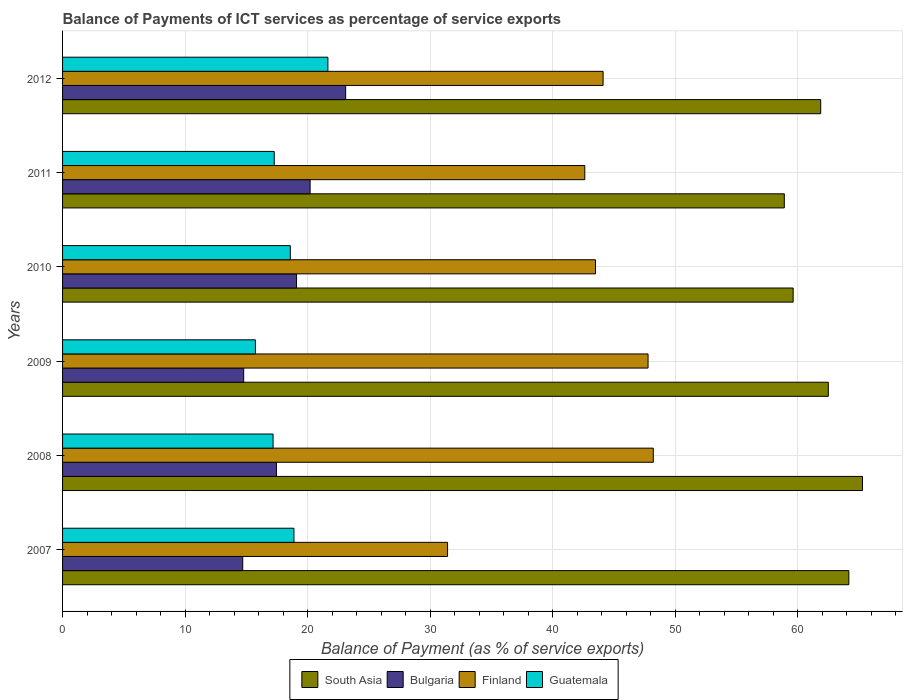How many groups of bars are there?
Provide a short and direct response. 6. Are the number of bars per tick equal to the number of legend labels?
Ensure brevity in your answer.  Yes. How many bars are there on the 2nd tick from the bottom?
Make the answer very short. 4. What is the label of the 1st group of bars from the top?
Provide a short and direct response. 2012. What is the balance of payments of ICT services in Bulgaria in 2008?
Offer a very short reply. 17.46. Across all years, what is the maximum balance of payments of ICT services in Guatemala?
Provide a short and direct response. 21.66. Across all years, what is the minimum balance of payments of ICT services in South Asia?
Your answer should be compact. 58.92. What is the total balance of payments of ICT services in Guatemala in the graph?
Keep it short and to the point. 109.34. What is the difference between the balance of payments of ICT services in Bulgaria in 2010 and that in 2012?
Keep it short and to the point. -4.01. What is the difference between the balance of payments of ICT services in Guatemala in 2011 and the balance of payments of ICT services in South Asia in 2007?
Provide a succinct answer. -46.91. What is the average balance of payments of ICT services in Guatemala per year?
Your answer should be very brief. 18.22. In the year 2007, what is the difference between the balance of payments of ICT services in Finland and balance of payments of ICT services in South Asia?
Give a very brief answer. -32.76. In how many years, is the balance of payments of ICT services in South Asia greater than 66 %?
Offer a terse response. 0. What is the ratio of the balance of payments of ICT services in Bulgaria in 2010 to that in 2011?
Your answer should be very brief. 0.95. Is the difference between the balance of payments of ICT services in Finland in 2010 and 2011 greater than the difference between the balance of payments of ICT services in South Asia in 2010 and 2011?
Ensure brevity in your answer.  Yes. What is the difference between the highest and the second highest balance of payments of ICT services in South Asia?
Ensure brevity in your answer.  1.11. What is the difference between the highest and the lowest balance of payments of ICT services in Finland?
Make the answer very short. 16.8. In how many years, is the balance of payments of ICT services in Guatemala greater than the average balance of payments of ICT services in Guatemala taken over all years?
Provide a short and direct response. 3. Is the sum of the balance of payments of ICT services in Guatemala in 2007 and 2009 greater than the maximum balance of payments of ICT services in Bulgaria across all years?
Your answer should be compact. Yes. Is it the case that in every year, the sum of the balance of payments of ICT services in Bulgaria and balance of payments of ICT services in Guatemala is greater than the sum of balance of payments of ICT services in South Asia and balance of payments of ICT services in Finland?
Give a very brief answer. No. What does the 3rd bar from the bottom in 2012 represents?
Your response must be concise. Finland. Is it the case that in every year, the sum of the balance of payments of ICT services in Finland and balance of payments of ICT services in Guatemala is greater than the balance of payments of ICT services in Bulgaria?
Provide a short and direct response. Yes. How many bars are there?
Provide a short and direct response. 24. Are all the bars in the graph horizontal?
Your answer should be very brief. Yes. How many years are there in the graph?
Make the answer very short. 6. Does the graph contain grids?
Give a very brief answer. Yes. How are the legend labels stacked?
Keep it short and to the point. Horizontal. What is the title of the graph?
Offer a very short reply. Balance of Payments of ICT services as percentage of service exports. What is the label or title of the X-axis?
Your answer should be compact. Balance of Payment (as % of service exports). What is the label or title of the Y-axis?
Offer a terse response. Years. What is the Balance of Payment (as % of service exports) of South Asia in 2007?
Keep it short and to the point. 64.18. What is the Balance of Payment (as % of service exports) of Bulgaria in 2007?
Your response must be concise. 14.71. What is the Balance of Payment (as % of service exports) of Finland in 2007?
Offer a terse response. 31.43. What is the Balance of Payment (as % of service exports) of Guatemala in 2007?
Provide a short and direct response. 18.89. What is the Balance of Payment (as % of service exports) of South Asia in 2008?
Ensure brevity in your answer.  65.3. What is the Balance of Payment (as % of service exports) in Bulgaria in 2008?
Keep it short and to the point. 17.46. What is the Balance of Payment (as % of service exports) of Finland in 2008?
Your answer should be compact. 48.22. What is the Balance of Payment (as % of service exports) of Guatemala in 2008?
Keep it short and to the point. 17.18. What is the Balance of Payment (as % of service exports) of South Asia in 2009?
Provide a succinct answer. 62.51. What is the Balance of Payment (as % of service exports) in Bulgaria in 2009?
Provide a short and direct response. 14.78. What is the Balance of Payment (as % of service exports) of Finland in 2009?
Your answer should be compact. 47.79. What is the Balance of Payment (as % of service exports) in Guatemala in 2009?
Your answer should be very brief. 15.74. What is the Balance of Payment (as % of service exports) in South Asia in 2010?
Give a very brief answer. 59.64. What is the Balance of Payment (as % of service exports) in Bulgaria in 2010?
Your response must be concise. 19.1. What is the Balance of Payment (as % of service exports) of Finland in 2010?
Give a very brief answer. 43.5. What is the Balance of Payment (as % of service exports) in Guatemala in 2010?
Your response must be concise. 18.59. What is the Balance of Payment (as % of service exports) in South Asia in 2011?
Offer a terse response. 58.92. What is the Balance of Payment (as % of service exports) in Bulgaria in 2011?
Your answer should be very brief. 20.21. What is the Balance of Payment (as % of service exports) of Finland in 2011?
Make the answer very short. 42.63. What is the Balance of Payment (as % of service exports) of Guatemala in 2011?
Give a very brief answer. 17.28. What is the Balance of Payment (as % of service exports) in South Asia in 2012?
Provide a succinct answer. 61.89. What is the Balance of Payment (as % of service exports) in Bulgaria in 2012?
Ensure brevity in your answer.  23.11. What is the Balance of Payment (as % of service exports) of Finland in 2012?
Your response must be concise. 44.12. What is the Balance of Payment (as % of service exports) of Guatemala in 2012?
Offer a terse response. 21.66. Across all years, what is the maximum Balance of Payment (as % of service exports) of South Asia?
Keep it short and to the point. 65.3. Across all years, what is the maximum Balance of Payment (as % of service exports) in Bulgaria?
Ensure brevity in your answer.  23.11. Across all years, what is the maximum Balance of Payment (as % of service exports) in Finland?
Provide a short and direct response. 48.22. Across all years, what is the maximum Balance of Payment (as % of service exports) in Guatemala?
Offer a terse response. 21.66. Across all years, what is the minimum Balance of Payment (as % of service exports) of South Asia?
Your answer should be very brief. 58.92. Across all years, what is the minimum Balance of Payment (as % of service exports) of Bulgaria?
Offer a very short reply. 14.71. Across all years, what is the minimum Balance of Payment (as % of service exports) in Finland?
Your response must be concise. 31.43. Across all years, what is the minimum Balance of Payment (as % of service exports) of Guatemala?
Give a very brief answer. 15.74. What is the total Balance of Payment (as % of service exports) of South Asia in the graph?
Your answer should be compact. 372.43. What is the total Balance of Payment (as % of service exports) in Bulgaria in the graph?
Make the answer very short. 109.37. What is the total Balance of Payment (as % of service exports) of Finland in the graph?
Ensure brevity in your answer.  257.7. What is the total Balance of Payment (as % of service exports) in Guatemala in the graph?
Provide a short and direct response. 109.34. What is the difference between the Balance of Payment (as % of service exports) of South Asia in 2007 and that in 2008?
Provide a short and direct response. -1.11. What is the difference between the Balance of Payment (as % of service exports) in Bulgaria in 2007 and that in 2008?
Ensure brevity in your answer.  -2.75. What is the difference between the Balance of Payment (as % of service exports) of Finland in 2007 and that in 2008?
Offer a terse response. -16.8. What is the difference between the Balance of Payment (as % of service exports) in Guatemala in 2007 and that in 2008?
Ensure brevity in your answer.  1.71. What is the difference between the Balance of Payment (as % of service exports) in South Asia in 2007 and that in 2009?
Provide a short and direct response. 1.68. What is the difference between the Balance of Payment (as % of service exports) in Bulgaria in 2007 and that in 2009?
Keep it short and to the point. -0.08. What is the difference between the Balance of Payment (as % of service exports) of Finland in 2007 and that in 2009?
Your answer should be compact. -16.37. What is the difference between the Balance of Payment (as % of service exports) in Guatemala in 2007 and that in 2009?
Your answer should be compact. 3.15. What is the difference between the Balance of Payment (as % of service exports) in South Asia in 2007 and that in 2010?
Provide a short and direct response. 4.54. What is the difference between the Balance of Payment (as % of service exports) in Bulgaria in 2007 and that in 2010?
Your response must be concise. -4.39. What is the difference between the Balance of Payment (as % of service exports) of Finland in 2007 and that in 2010?
Make the answer very short. -12.08. What is the difference between the Balance of Payment (as % of service exports) of Guatemala in 2007 and that in 2010?
Provide a succinct answer. 0.3. What is the difference between the Balance of Payment (as % of service exports) of South Asia in 2007 and that in 2011?
Ensure brevity in your answer.  5.27. What is the difference between the Balance of Payment (as % of service exports) of Bulgaria in 2007 and that in 2011?
Keep it short and to the point. -5.5. What is the difference between the Balance of Payment (as % of service exports) in Finland in 2007 and that in 2011?
Keep it short and to the point. -11.2. What is the difference between the Balance of Payment (as % of service exports) in Guatemala in 2007 and that in 2011?
Ensure brevity in your answer.  1.61. What is the difference between the Balance of Payment (as % of service exports) of South Asia in 2007 and that in 2012?
Make the answer very short. 2.3. What is the difference between the Balance of Payment (as % of service exports) of Bulgaria in 2007 and that in 2012?
Provide a short and direct response. -8.4. What is the difference between the Balance of Payment (as % of service exports) of Finland in 2007 and that in 2012?
Give a very brief answer. -12.7. What is the difference between the Balance of Payment (as % of service exports) in Guatemala in 2007 and that in 2012?
Your response must be concise. -2.77. What is the difference between the Balance of Payment (as % of service exports) in South Asia in 2008 and that in 2009?
Give a very brief answer. 2.79. What is the difference between the Balance of Payment (as % of service exports) of Bulgaria in 2008 and that in 2009?
Provide a succinct answer. 2.67. What is the difference between the Balance of Payment (as % of service exports) of Finland in 2008 and that in 2009?
Provide a succinct answer. 0.43. What is the difference between the Balance of Payment (as % of service exports) of Guatemala in 2008 and that in 2009?
Provide a succinct answer. 1.44. What is the difference between the Balance of Payment (as % of service exports) in South Asia in 2008 and that in 2010?
Provide a short and direct response. 5.66. What is the difference between the Balance of Payment (as % of service exports) of Bulgaria in 2008 and that in 2010?
Your response must be concise. -1.64. What is the difference between the Balance of Payment (as % of service exports) of Finland in 2008 and that in 2010?
Your answer should be compact. 4.72. What is the difference between the Balance of Payment (as % of service exports) in Guatemala in 2008 and that in 2010?
Provide a short and direct response. -1.41. What is the difference between the Balance of Payment (as % of service exports) in South Asia in 2008 and that in 2011?
Keep it short and to the point. 6.38. What is the difference between the Balance of Payment (as % of service exports) in Bulgaria in 2008 and that in 2011?
Make the answer very short. -2.75. What is the difference between the Balance of Payment (as % of service exports) in Finland in 2008 and that in 2011?
Offer a terse response. 5.59. What is the difference between the Balance of Payment (as % of service exports) of Guatemala in 2008 and that in 2011?
Give a very brief answer. -0.09. What is the difference between the Balance of Payment (as % of service exports) in South Asia in 2008 and that in 2012?
Provide a short and direct response. 3.41. What is the difference between the Balance of Payment (as % of service exports) of Bulgaria in 2008 and that in 2012?
Your response must be concise. -5.65. What is the difference between the Balance of Payment (as % of service exports) in Finland in 2008 and that in 2012?
Make the answer very short. 4.1. What is the difference between the Balance of Payment (as % of service exports) in Guatemala in 2008 and that in 2012?
Offer a terse response. -4.48. What is the difference between the Balance of Payment (as % of service exports) of South Asia in 2009 and that in 2010?
Provide a succinct answer. 2.87. What is the difference between the Balance of Payment (as % of service exports) in Bulgaria in 2009 and that in 2010?
Offer a terse response. -4.31. What is the difference between the Balance of Payment (as % of service exports) in Finland in 2009 and that in 2010?
Your answer should be very brief. 4.29. What is the difference between the Balance of Payment (as % of service exports) of Guatemala in 2009 and that in 2010?
Keep it short and to the point. -2.85. What is the difference between the Balance of Payment (as % of service exports) of South Asia in 2009 and that in 2011?
Provide a succinct answer. 3.59. What is the difference between the Balance of Payment (as % of service exports) of Bulgaria in 2009 and that in 2011?
Ensure brevity in your answer.  -5.42. What is the difference between the Balance of Payment (as % of service exports) of Finland in 2009 and that in 2011?
Your answer should be compact. 5.16. What is the difference between the Balance of Payment (as % of service exports) of Guatemala in 2009 and that in 2011?
Your answer should be very brief. -1.54. What is the difference between the Balance of Payment (as % of service exports) of South Asia in 2009 and that in 2012?
Provide a succinct answer. 0.62. What is the difference between the Balance of Payment (as % of service exports) in Bulgaria in 2009 and that in 2012?
Offer a terse response. -8.32. What is the difference between the Balance of Payment (as % of service exports) in Finland in 2009 and that in 2012?
Offer a terse response. 3.67. What is the difference between the Balance of Payment (as % of service exports) in Guatemala in 2009 and that in 2012?
Your response must be concise. -5.92. What is the difference between the Balance of Payment (as % of service exports) in South Asia in 2010 and that in 2011?
Keep it short and to the point. 0.72. What is the difference between the Balance of Payment (as % of service exports) in Bulgaria in 2010 and that in 2011?
Offer a very short reply. -1.11. What is the difference between the Balance of Payment (as % of service exports) in Finland in 2010 and that in 2011?
Offer a very short reply. 0.87. What is the difference between the Balance of Payment (as % of service exports) of Guatemala in 2010 and that in 2011?
Give a very brief answer. 1.31. What is the difference between the Balance of Payment (as % of service exports) of South Asia in 2010 and that in 2012?
Keep it short and to the point. -2.25. What is the difference between the Balance of Payment (as % of service exports) in Bulgaria in 2010 and that in 2012?
Provide a short and direct response. -4.01. What is the difference between the Balance of Payment (as % of service exports) in Finland in 2010 and that in 2012?
Your response must be concise. -0.62. What is the difference between the Balance of Payment (as % of service exports) of Guatemala in 2010 and that in 2012?
Your answer should be compact. -3.07. What is the difference between the Balance of Payment (as % of service exports) of South Asia in 2011 and that in 2012?
Your answer should be very brief. -2.97. What is the difference between the Balance of Payment (as % of service exports) in Bulgaria in 2011 and that in 2012?
Your answer should be very brief. -2.9. What is the difference between the Balance of Payment (as % of service exports) in Finland in 2011 and that in 2012?
Your answer should be very brief. -1.49. What is the difference between the Balance of Payment (as % of service exports) of Guatemala in 2011 and that in 2012?
Offer a very short reply. -4.38. What is the difference between the Balance of Payment (as % of service exports) of South Asia in 2007 and the Balance of Payment (as % of service exports) of Bulgaria in 2008?
Offer a terse response. 46.73. What is the difference between the Balance of Payment (as % of service exports) in South Asia in 2007 and the Balance of Payment (as % of service exports) in Finland in 2008?
Offer a terse response. 15.96. What is the difference between the Balance of Payment (as % of service exports) of South Asia in 2007 and the Balance of Payment (as % of service exports) of Guatemala in 2008?
Your answer should be compact. 47. What is the difference between the Balance of Payment (as % of service exports) of Bulgaria in 2007 and the Balance of Payment (as % of service exports) of Finland in 2008?
Give a very brief answer. -33.51. What is the difference between the Balance of Payment (as % of service exports) of Bulgaria in 2007 and the Balance of Payment (as % of service exports) of Guatemala in 2008?
Ensure brevity in your answer.  -2.48. What is the difference between the Balance of Payment (as % of service exports) in Finland in 2007 and the Balance of Payment (as % of service exports) in Guatemala in 2008?
Your answer should be compact. 14.24. What is the difference between the Balance of Payment (as % of service exports) in South Asia in 2007 and the Balance of Payment (as % of service exports) in Bulgaria in 2009?
Keep it short and to the point. 49.4. What is the difference between the Balance of Payment (as % of service exports) in South Asia in 2007 and the Balance of Payment (as % of service exports) in Finland in 2009?
Make the answer very short. 16.39. What is the difference between the Balance of Payment (as % of service exports) in South Asia in 2007 and the Balance of Payment (as % of service exports) in Guatemala in 2009?
Keep it short and to the point. 48.44. What is the difference between the Balance of Payment (as % of service exports) of Bulgaria in 2007 and the Balance of Payment (as % of service exports) of Finland in 2009?
Ensure brevity in your answer.  -33.09. What is the difference between the Balance of Payment (as % of service exports) in Bulgaria in 2007 and the Balance of Payment (as % of service exports) in Guatemala in 2009?
Provide a short and direct response. -1.03. What is the difference between the Balance of Payment (as % of service exports) of Finland in 2007 and the Balance of Payment (as % of service exports) of Guatemala in 2009?
Keep it short and to the point. 15.69. What is the difference between the Balance of Payment (as % of service exports) of South Asia in 2007 and the Balance of Payment (as % of service exports) of Bulgaria in 2010?
Keep it short and to the point. 45.08. What is the difference between the Balance of Payment (as % of service exports) of South Asia in 2007 and the Balance of Payment (as % of service exports) of Finland in 2010?
Make the answer very short. 20.68. What is the difference between the Balance of Payment (as % of service exports) of South Asia in 2007 and the Balance of Payment (as % of service exports) of Guatemala in 2010?
Provide a succinct answer. 45.59. What is the difference between the Balance of Payment (as % of service exports) in Bulgaria in 2007 and the Balance of Payment (as % of service exports) in Finland in 2010?
Ensure brevity in your answer.  -28.79. What is the difference between the Balance of Payment (as % of service exports) of Bulgaria in 2007 and the Balance of Payment (as % of service exports) of Guatemala in 2010?
Keep it short and to the point. -3.88. What is the difference between the Balance of Payment (as % of service exports) of Finland in 2007 and the Balance of Payment (as % of service exports) of Guatemala in 2010?
Make the answer very short. 12.84. What is the difference between the Balance of Payment (as % of service exports) in South Asia in 2007 and the Balance of Payment (as % of service exports) in Bulgaria in 2011?
Provide a succinct answer. 43.98. What is the difference between the Balance of Payment (as % of service exports) in South Asia in 2007 and the Balance of Payment (as % of service exports) in Finland in 2011?
Provide a succinct answer. 21.55. What is the difference between the Balance of Payment (as % of service exports) in South Asia in 2007 and the Balance of Payment (as % of service exports) in Guatemala in 2011?
Provide a succinct answer. 46.91. What is the difference between the Balance of Payment (as % of service exports) in Bulgaria in 2007 and the Balance of Payment (as % of service exports) in Finland in 2011?
Offer a very short reply. -27.92. What is the difference between the Balance of Payment (as % of service exports) in Bulgaria in 2007 and the Balance of Payment (as % of service exports) in Guatemala in 2011?
Provide a succinct answer. -2.57. What is the difference between the Balance of Payment (as % of service exports) in Finland in 2007 and the Balance of Payment (as % of service exports) in Guatemala in 2011?
Ensure brevity in your answer.  14.15. What is the difference between the Balance of Payment (as % of service exports) in South Asia in 2007 and the Balance of Payment (as % of service exports) in Bulgaria in 2012?
Keep it short and to the point. 41.07. What is the difference between the Balance of Payment (as % of service exports) in South Asia in 2007 and the Balance of Payment (as % of service exports) in Finland in 2012?
Provide a short and direct response. 20.06. What is the difference between the Balance of Payment (as % of service exports) in South Asia in 2007 and the Balance of Payment (as % of service exports) in Guatemala in 2012?
Offer a very short reply. 42.52. What is the difference between the Balance of Payment (as % of service exports) of Bulgaria in 2007 and the Balance of Payment (as % of service exports) of Finland in 2012?
Your answer should be very brief. -29.42. What is the difference between the Balance of Payment (as % of service exports) in Bulgaria in 2007 and the Balance of Payment (as % of service exports) in Guatemala in 2012?
Offer a very short reply. -6.95. What is the difference between the Balance of Payment (as % of service exports) in Finland in 2007 and the Balance of Payment (as % of service exports) in Guatemala in 2012?
Provide a succinct answer. 9.77. What is the difference between the Balance of Payment (as % of service exports) of South Asia in 2008 and the Balance of Payment (as % of service exports) of Bulgaria in 2009?
Provide a succinct answer. 50.51. What is the difference between the Balance of Payment (as % of service exports) of South Asia in 2008 and the Balance of Payment (as % of service exports) of Finland in 2009?
Your answer should be compact. 17.5. What is the difference between the Balance of Payment (as % of service exports) in South Asia in 2008 and the Balance of Payment (as % of service exports) in Guatemala in 2009?
Offer a terse response. 49.56. What is the difference between the Balance of Payment (as % of service exports) in Bulgaria in 2008 and the Balance of Payment (as % of service exports) in Finland in 2009?
Your response must be concise. -30.34. What is the difference between the Balance of Payment (as % of service exports) of Bulgaria in 2008 and the Balance of Payment (as % of service exports) of Guatemala in 2009?
Offer a terse response. 1.72. What is the difference between the Balance of Payment (as % of service exports) of Finland in 2008 and the Balance of Payment (as % of service exports) of Guatemala in 2009?
Offer a terse response. 32.48. What is the difference between the Balance of Payment (as % of service exports) of South Asia in 2008 and the Balance of Payment (as % of service exports) of Bulgaria in 2010?
Offer a very short reply. 46.2. What is the difference between the Balance of Payment (as % of service exports) of South Asia in 2008 and the Balance of Payment (as % of service exports) of Finland in 2010?
Your answer should be very brief. 21.8. What is the difference between the Balance of Payment (as % of service exports) of South Asia in 2008 and the Balance of Payment (as % of service exports) of Guatemala in 2010?
Offer a very short reply. 46.71. What is the difference between the Balance of Payment (as % of service exports) of Bulgaria in 2008 and the Balance of Payment (as % of service exports) of Finland in 2010?
Provide a short and direct response. -26.04. What is the difference between the Balance of Payment (as % of service exports) in Bulgaria in 2008 and the Balance of Payment (as % of service exports) in Guatemala in 2010?
Offer a very short reply. -1.13. What is the difference between the Balance of Payment (as % of service exports) of Finland in 2008 and the Balance of Payment (as % of service exports) of Guatemala in 2010?
Make the answer very short. 29.63. What is the difference between the Balance of Payment (as % of service exports) in South Asia in 2008 and the Balance of Payment (as % of service exports) in Bulgaria in 2011?
Your answer should be very brief. 45.09. What is the difference between the Balance of Payment (as % of service exports) in South Asia in 2008 and the Balance of Payment (as % of service exports) in Finland in 2011?
Make the answer very short. 22.67. What is the difference between the Balance of Payment (as % of service exports) of South Asia in 2008 and the Balance of Payment (as % of service exports) of Guatemala in 2011?
Provide a short and direct response. 48.02. What is the difference between the Balance of Payment (as % of service exports) of Bulgaria in 2008 and the Balance of Payment (as % of service exports) of Finland in 2011?
Make the answer very short. -25.17. What is the difference between the Balance of Payment (as % of service exports) of Bulgaria in 2008 and the Balance of Payment (as % of service exports) of Guatemala in 2011?
Offer a terse response. 0.18. What is the difference between the Balance of Payment (as % of service exports) in Finland in 2008 and the Balance of Payment (as % of service exports) in Guatemala in 2011?
Offer a very short reply. 30.94. What is the difference between the Balance of Payment (as % of service exports) of South Asia in 2008 and the Balance of Payment (as % of service exports) of Bulgaria in 2012?
Ensure brevity in your answer.  42.19. What is the difference between the Balance of Payment (as % of service exports) in South Asia in 2008 and the Balance of Payment (as % of service exports) in Finland in 2012?
Provide a short and direct response. 21.17. What is the difference between the Balance of Payment (as % of service exports) of South Asia in 2008 and the Balance of Payment (as % of service exports) of Guatemala in 2012?
Ensure brevity in your answer.  43.64. What is the difference between the Balance of Payment (as % of service exports) in Bulgaria in 2008 and the Balance of Payment (as % of service exports) in Finland in 2012?
Provide a succinct answer. -26.67. What is the difference between the Balance of Payment (as % of service exports) of Bulgaria in 2008 and the Balance of Payment (as % of service exports) of Guatemala in 2012?
Make the answer very short. -4.2. What is the difference between the Balance of Payment (as % of service exports) of Finland in 2008 and the Balance of Payment (as % of service exports) of Guatemala in 2012?
Offer a terse response. 26.56. What is the difference between the Balance of Payment (as % of service exports) in South Asia in 2009 and the Balance of Payment (as % of service exports) in Bulgaria in 2010?
Keep it short and to the point. 43.41. What is the difference between the Balance of Payment (as % of service exports) of South Asia in 2009 and the Balance of Payment (as % of service exports) of Finland in 2010?
Keep it short and to the point. 19.01. What is the difference between the Balance of Payment (as % of service exports) in South Asia in 2009 and the Balance of Payment (as % of service exports) in Guatemala in 2010?
Give a very brief answer. 43.92. What is the difference between the Balance of Payment (as % of service exports) of Bulgaria in 2009 and the Balance of Payment (as % of service exports) of Finland in 2010?
Provide a short and direct response. -28.72. What is the difference between the Balance of Payment (as % of service exports) of Bulgaria in 2009 and the Balance of Payment (as % of service exports) of Guatemala in 2010?
Provide a succinct answer. -3.81. What is the difference between the Balance of Payment (as % of service exports) of Finland in 2009 and the Balance of Payment (as % of service exports) of Guatemala in 2010?
Keep it short and to the point. 29.2. What is the difference between the Balance of Payment (as % of service exports) of South Asia in 2009 and the Balance of Payment (as % of service exports) of Bulgaria in 2011?
Ensure brevity in your answer.  42.3. What is the difference between the Balance of Payment (as % of service exports) in South Asia in 2009 and the Balance of Payment (as % of service exports) in Finland in 2011?
Offer a very short reply. 19.88. What is the difference between the Balance of Payment (as % of service exports) in South Asia in 2009 and the Balance of Payment (as % of service exports) in Guatemala in 2011?
Your answer should be very brief. 45.23. What is the difference between the Balance of Payment (as % of service exports) in Bulgaria in 2009 and the Balance of Payment (as % of service exports) in Finland in 2011?
Provide a succinct answer. -27.85. What is the difference between the Balance of Payment (as % of service exports) of Bulgaria in 2009 and the Balance of Payment (as % of service exports) of Guatemala in 2011?
Offer a terse response. -2.49. What is the difference between the Balance of Payment (as % of service exports) in Finland in 2009 and the Balance of Payment (as % of service exports) in Guatemala in 2011?
Offer a terse response. 30.52. What is the difference between the Balance of Payment (as % of service exports) in South Asia in 2009 and the Balance of Payment (as % of service exports) in Bulgaria in 2012?
Offer a very short reply. 39.4. What is the difference between the Balance of Payment (as % of service exports) in South Asia in 2009 and the Balance of Payment (as % of service exports) in Finland in 2012?
Your answer should be very brief. 18.38. What is the difference between the Balance of Payment (as % of service exports) of South Asia in 2009 and the Balance of Payment (as % of service exports) of Guatemala in 2012?
Your answer should be very brief. 40.85. What is the difference between the Balance of Payment (as % of service exports) of Bulgaria in 2009 and the Balance of Payment (as % of service exports) of Finland in 2012?
Your answer should be very brief. -29.34. What is the difference between the Balance of Payment (as % of service exports) in Bulgaria in 2009 and the Balance of Payment (as % of service exports) in Guatemala in 2012?
Your answer should be compact. -6.87. What is the difference between the Balance of Payment (as % of service exports) in Finland in 2009 and the Balance of Payment (as % of service exports) in Guatemala in 2012?
Provide a short and direct response. 26.14. What is the difference between the Balance of Payment (as % of service exports) in South Asia in 2010 and the Balance of Payment (as % of service exports) in Bulgaria in 2011?
Ensure brevity in your answer.  39.43. What is the difference between the Balance of Payment (as % of service exports) of South Asia in 2010 and the Balance of Payment (as % of service exports) of Finland in 2011?
Your answer should be compact. 17.01. What is the difference between the Balance of Payment (as % of service exports) in South Asia in 2010 and the Balance of Payment (as % of service exports) in Guatemala in 2011?
Your response must be concise. 42.36. What is the difference between the Balance of Payment (as % of service exports) of Bulgaria in 2010 and the Balance of Payment (as % of service exports) of Finland in 2011?
Provide a succinct answer. -23.53. What is the difference between the Balance of Payment (as % of service exports) in Bulgaria in 2010 and the Balance of Payment (as % of service exports) in Guatemala in 2011?
Ensure brevity in your answer.  1.82. What is the difference between the Balance of Payment (as % of service exports) of Finland in 2010 and the Balance of Payment (as % of service exports) of Guatemala in 2011?
Your answer should be very brief. 26.22. What is the difference between the Balance of Payment (as % of service exports) of South Asia in 2010 and the Balance of Payment (as % of service exports) of Bulgaria in 2012?
Your answer should be very brief. 36.53. What is the difference between the Balance of Payment (as % of service exports) of South Asia in 2010 and the Balance of Payment (as % of service exports) of Finland in 2012?
Your response must be concise. 15.52. What is the difference between the Balance of Payment (as % of service exports) of South Asia in 2010 and the Balance of Payment (as % of service exports) of Guatemala in 2012?
Make the answer very short. 37.98. What is the difference between the Balance of Payment (as % of service exports) of Bulgaria in 2010 and the Balance of Payment (as % of service exports) of Finland in 2012?
Your answer should be compact. -25.02. What is the difference between the Balance of Payment (as % of service exports) in Bulgaria in 2010 and the Balance of Payment (as % of service exports) in Guatemala in 2012?
Offer a very short reply. -2.56. What is the difference between the Balance of Payment (as % of service exports) in Finland in 2010 and the Balance of Payment (as % of service exports) in Guatemala in 2012?
Keep it short and to the point. 21.84. What is the difference between the Balance of Payment (as % of service exports) in South Asia in 2011 and the Balance of Payment (as % of service exports) in Bulgaria in 2012?
Offer a very short reply. 35.81. What is the difference between the Balance of Payment (as % of service exports) of South Asia in 2011 and the Balance of Payment (as % of service exports) of Finland in 2012?
Provide a short and direct response. 14.79. What is the difference between the Balance of Payment (as % of service exports) of South Asia in 2011 and the Balance of Payment (as % of service exports) of Guatemala in 2012?
Provide a short and direct response. 37.26. What is the difference between the Balance of Payment (as % of service exports) of Bulgaria in 2011 and the Balance of Payment (as % of service exports) of Finland in 2012?
Provide a short and direct response. -23.92. What is the difference between the Balance of Payment (as % of service exports) of Bulgaria in 2011 and the Balance of Payment (as % of service exports) of Guatemala in 2012?
Give a very brief answer. -1.45. What is the difference between the Balance of Payment (as % of service exports) of Finland in 2011 and the Balance of Payment (as % of service exports) of Guatemala in 2012?
Your response must be concise. 20.97. What is the average Balance of Payment (as % of service exports) in South Asia per year?
Ensure brevity in your answer.  62.07. What is the average Balance of Payment (as % of service exports) in Bulgaria per year?
Offer a very short reply. 18.23. What is the average Balance of Payment (as % of service exports) of Finland per year?
Your response must be concise. 42.95. What is the average Balance of Payment (as % of service exports) of Guatemala per year?
Your response must be concise. 18.22. In the year 2007, what is the difference between the Balance of Payment (as % of service exports) of South Asia and Balance of Payment (as % of service exports) of Bulgaria?
Ensure brevity in your answer.  49.48. In the year 2007, what is the difference between the Balance of Payment (as % of service exports) in South Asia and Balance of Payment (as % of service exports) in Finland?
Provide a succinct answer. 32.76. In the year 2007, what is the difference between the Balance of Payment (as % of service exports) of South Asia and Balance of Payment (as % of service exports) of Guatemala?
Provide a short and direct response. 45.3. In the year 2007, what is the difference between the Balance of Payment (as % of service exports) in Bulgaria and Balance of Payment (as % of service exports) in Finland?
Provide a succinct answer. -16.72. In the year 2007, what is the difference between the Balance of Payment (as % of service exports) of Bulgaria and Balance of Payment (as % of service exports) of Guatemala?
Make the answer very short. -4.18. In the year 2007, what is the difference between the Balance of Payment (as % of service exports) in Finland and Balance of Payment (as % of service exports) in Guatemala?
Make the answer very short. 12.54. In the year 2008, what is the difference between the Balance of Payment (as % of service exports) of South Asia and Balance of Payment (as % of service exports) of Bulgaria?
Your answer should be compact. 47.84. In the year 2008, what is the difference between the Balance of Payment (as % of service exports) of South Asia and Balance of Payment (as % of service exports) of Finland?
Keep it short and to the point. 17.08. In the year 2008, what is the difference between the Balance of Payment (as % of service exports) in South Asia and Balance of Payment (as % of service exports) in Guatemala?
Provide a succinct answer. 48.12. In the year 2008, what is the difference between the Balance of Payment (as % of service exports) in Bulgaria and Balance of Payment (as % of service exports) in Finland?
Offer a very short reply. -30.76. In the year 2008, what is the difference between the Balance of Payment (as % of service exports) in Bulgaria and Balance of Payment (as % of service exports) in Guatemala?
Your response must be concise. 0.28. In the year 2008, what is the difference between the Balance of Payment (as % of service exports) of Finland and Balance of Payment (as % of service exports) of Guatemala?
Offer a terse response. 31.04. In the year 2009, what is the difference between the Balance of Payment (as % of service exports) of South Asia and Balance of Payment (as % of service exports) of Bulgaria?
Provide a short and direct response. 47.72. In the year 2009, what is the difference between the Balance of Payment (as % of service exports) in South Asia and Balance of Payment (as % of service exports) in Finland?
Provide a succinct answer. 14.71. In the year 2009, what is the difference between the Balance of Payment (as % of service exports) in South Asia and Balance of Payment (as % of service exports) in Guatemala?
Offer a very short reply. 46.77. In the year 2009, what is the difference between the Balance of Payment (as % of service exports) of Bulgaria and Balance of Payment (as % of service exports) of Finland?
Ensure brevity in your answer.  -33.01. In the year 2009, what is the difference between the Balance of Payment (as % of service exports) of Bulgaria and Balance of Payment (as % of service exports) of Guatemala?
Ensure brevity in your answer.  -0.96. In the year 2009, what is the difference between the Balance of Payment (as % of service exports) in Finland and Balance of Payment (as % of service exports) in Guatemala?
Offer a very short reply. 32.05. In the year 2010, what is the difference between the Balance of Payment (as % of service exports) in South Asia and Balance of Payment (as % of service exports) in Bulgaria?
Make the answer very short. 40.54. In the year 2010, what is the difference between the Balance of Payment (as % of service exports) in South Asia and Balance of Payment (as % of service exports) in Finland?
Give a very brief answer. 16.14. In the year 2010, what is the difference between the Balance of Payment (as % of service exports) in South Asia and Balance of Payment (as % of service exports) in Guatemala?
Provide a short and direct response. 41.05. In the year 2010, what is the difference between the Balance of Payment (as % of service exports) in Bulgaria and Balance of Payment (as % of service exports) in Finland?
Your answer should be very brief. -24.4. In the year 2010, what is the difference between the Balance of Payment (as % of service exports) in Bulgaria and Balance of Payment (as % of service exports) in Guatemala?
Make the answer very short. 0.51. In the year 2010, what is the difference between the Balance of Payment (as % of service exports) of Finland and Balance of Payment (as % of service exports) of Guatemala?
Provide a succinct answer. 24.91. In the year 2011, what is the difference between the Balance of Payment (as % of service exports) in South Asia and Balance of Payment (as % of service exports) in Bulgaria?
Offer a terse response. 38.71. In the year 2011, what is the difference between the Balance of Payment (as % of service exports) in South Asia and Balance of Payment (as % of service exports) in Finland?
Provide a succinct answer. 16.29. In the year 2011, what is the difference between the Balance of Payment (as % of service exports) in South Asia and Balance of Payment (as % of service exports) in Guatemala?
Your answer should be very brief. 41.64. In the year 2011, what is the difference between the Balance of Payment (as % of service exports) in Bulgaria and Balance of Payment (as % of service exports) in Finland?
Ensure brevity in your answer.  -22.42. In the year 2011, what is the difference between the Balance of Payment (as % of service exports) of Bulgaria and Balance of Payment (as % of service exports) of Guatemala?
Offer a very short reply. 2.93. In the year 2011, what is the difference between the Balance of Payment (as % of service exports) in Finland and Balance of Payment (as % of service exports) in Guatemala?
Ensure brevity in your answer.  25.35. In the year 2012, what is the difference between the Balance of Payment (as % of service exports) of South Asia and Balance of Payment (as % of service exports) of Bulgaria?
Offer a very short reply. 38.78. In the year 2012, what is the difference between the Balance of Payment (as % of service exports) in South Asia and Balance of Payment (as % of service exports) in Finland?
Keep it short and to the point. 17.76. In the year 2012, what is the difference between the Balance of Payment (as % of service exports) in South Asia and Balance of Payment (as % of service exports) in Guatemala?
Make the answer very short. 40.23. In the year 2012, what is the difference between the Balance of Payment (as % of service exports) of Bulgaria and Balance of Payment (as % of service exports) of Finland?
Make the answer very short. -21.01. In the year 2012, what is the difference between the Balance of Payment (as % of service exports) of Bulgaria and Balance of Payment (as % of service exports) of Guatemala?
Your answer should be compact. 1.45. In the year 2012, what is the difference between the Balance of Payment (as % of service exports) of Finland and Balance of Payment (as % of service exports) of Guatemala?
Your response must be concise. 22.46. What is the ratio of the Balance of Payment (as % of service exports) in South Asia in 2007 to that in 2008?
Keep it short and to the point. 0.98. What is the ratio of the Balance of Payment (as % of service exports) in Bulgaria in 2007 to that in 2008?
Provide a short and direct response. 0.84. What is the ratio of the Balance of Payment (as % of service exports) of Finland in 2007 to that in 2008?
Your answer should be compact. 0.65. What is the ratio of the Balance of Payment (as % of service exports) of Guatemala in 2007 to that in 2008?
Ensure brevity in your answer.  1.1. What is the ratio of the Balance of Payment (as % of service exports) of South Asia in 2007 to that in 2009?
Make the answer very short. 1.03. What is the ratio of the Balance of Payment (as % of service exports) of Finland in 2007 to that in 2009?
Give a very brief answer. 0.66. What is the ratio of the Balance of Payment (as % of service exports) in Guatemala in 2007 to that in 2009?
Keep it short and to the point. 1.2. What is the ratio of the Balance of Payment (as % of service exports) in South Asia in 2007 to that in 2010?
Give a very brief answer. 1.08. What is the ratio of the Balance of Payment (as % of service exports) in Bulgaria in 2007 to that in 2010?
Your response must be concise. 0.77. What is the ratio of the Balance of Payment (as % of service exports) in Finland in 2007 to that in 2010?
Offer a terse response. 0.72. What is the ratio of the Balance of Payment (as % of service exports) of Guatemala in 2007 to that in 2010?
Make the answer very short. 1.02. What is the ratio of the Balance of Payment (as % of service exports) in South Asia in 2007 to that in 2011?
Make the answer very short. 1.09. What is the ratio of the Balance of Payment (as % of service exports) of Bulgaria in 2007 to that in 2011?
Your answer should be compact. 0.73. What is the ratio of the Balance of Payment (as % of service exports) of Finland in 2007 to that in 2011?
Give a very brief answer. 0.74. What is the ratio of the Balance of Payment (as % of service exports) of Guatemala in 2007 to that in 2011?
Give a very brief answer. 1.09. What is the ratio of the Balance of Payment (as % of service exports) in South Asia in 2007 to that in 2012?
Give a very brief answer. 1.04. What is the ratio of the Balance of Payment (as % of service exports) of Bulgaria in 2007 to that in 2012?
Offer a very short reply. 0.64. What is the ratio of the Balance of Payment (as % of service exports) of Finland in 2007 to that in 2012?
Ensure brevity in your answer.  0.71. What is the ratio of the Balance of Payment (as % of service exports) of Guatemala in 2007 to that in 2012?
Give a very brief answer. 0.87. What is the ratio of the Balance of Payment (as % of service exports) in South Asia in 2008 to that in 2009?
Ensure brevity in your answer.  1.04. What is the ratio of the Balance of Payment (as % of service exports) of Bulgaria in 2008 to that in 2009?
Your answer should be very brief. 1.18. What is the ratio of the Balance of Payment (as % of service exports) of Guatemala in 2008 to that in 2009?
Provide a short and direct response. 1.09. What is the ratio of the Balance of Payment (as % of service exports) in South Asia in 2008 to that in 2010?
Your answer should be very brief. 1.09. What is the ratio of the Balance of Payment (as % of service exports) in Bulgaria in 2008 to that in 2010?
Make the answer very short. 0.91. What is the ratio of the Balance of Payment (as % of service exports) in Finland in 2008 to that in 2010?
Ensure brevity in your answer.  1.11. What is the ratio of the Balance of Payment (as % of service exports) of Guatemala in 2008 to that in 2010?
Make the answer very short. 0.92. What is the ratio of the Balance of Payment (as % of service exports) in South Asia in 2008 to that in 2011?
Give a very brief answer. 1.11. What is the ratio of the Balance of Payment (as % of service exports) of Bulgaria in 2008 to that in 2011?
Provide a succinct answer. 0.86. What is the ratio of the Balance of Payment (as % of service exports) of Finland in 2008 to that in 2011?
Provide a short and direct response. 1.13. What is the ratio of the Balance of Payment (as % of service exports) in Guatemala in 2008 to that in 2011?
Keep it short and to the point. 0.99. What is the ratio of the Balance of Payment (as % of service exports) in South Asia in 2008 to that in 2012?
Your answer should be compact. 1.06. What is the ratio of the Balance of Payment (as % of service exports) of Bulgaria in 2008 to that in 2012?
Offer a terse response. 0.76. What is the ratio of the Balance of Payment (as % of service exports) in Finland in 2008 to that in 2012?
Your answer should be compact. 1.09. What is the ratio of the Balance of Payment (as % of service exports) in Guatemala in 2008 to that in 2012?
Offer a very short reply. 0.79. What is the ratio of the Balance of Payment (as % of service exports) of South Asia in 2009 to that in 2010?
Offer a very short reply. 1.05. What is the ratio of the Balance of Payment (as % of service exports) of Bulgaria in 2009 to that in 2010?
Your response must be concise. 0.77. What is the ratio of the Balance of Payment (as % of service exports) of Finland in 2009 to that in 2010?
Give a very brief answer. 1.1. What is the ratio of the Balance of Payment (as % of service exports) in Guatemala in 2009 to that in 2010?
Offer a terse response. 0.85. What is the ratio of the Balance of Payment (as % of service exports) of South Asia in 2009 to that in 2011?
Ensure brevity in your answer.  1.06. What is the ratio of the Balance of Payment (as % of service exports) in Bulgaria in 2009 to that in 2011?
Your answer should be compact. 0.73. What is the ratio of the Balance of Payment (as % of service exports) of Finland in 2009 to that in 2011?
Your answer should be very brief. 1.12. What is the ratio of the Balance of Payment (as % of service exports) in Guatemala in 2009 to that in 2011?
Ensure brevity in your answer.  0.91. What is the ratio of the Balance of Payment (as % of service exports) in Bulgaria in 2009 to that in 2012?
Offer a very short reply. 0.64. What is the ratio of the Balance of Payment (as % of service exports) in Finland in 2009 to that in 2012?
Ensure brevity in your answer.  1.08. What is the ratio of the Balance of Payment (as % of service exports) of Guatemala in 2009 to that in 2012?
Your response must be concise. 0.73. What is the ratio of the Balance of Payment (as % of service exports) in South Asia in 2010 to that in 2011?
Your response must be concise. 1.01. What is the ratio of the Balance of Payment (as % of service exports) in Bulgaria in 2010 to that in 2011?
Provide a short and direct response. 0.95. What is the ratio of the Balance of Payment (as % of service exports) in Finland in 2010 to that in 2011?
Offer a terse response. 1.02. What is the ratio of the Balance of Payment (as % of service exports) of Guatemala in 2010 to that in 2011?
Provide a short and direct response. 1.08. What is the ratio of the Balance of Payment (as % of service exports) of South Asia in 2010 to that in 2012?
Make the answer very short. 0.96. What is the ratio of the Balance of Payment (as % of service exports) in Bulgaria in 2010 to that in 2012?
Your answer should be very brief. 0.83. What is the ratio of the Balance of Payment (as % of service exports) in Finland in 2010 to that in 2012?
Offer a terse response. 0.99. What is the ratio of the Balance of Payment (as % of service exports) of Guatemala in 2010 to that in 2012?
Your answer should be compact. 0.86. What is the ratio of the Balance of Payment (as % of service exports) in Bulgaria in 2011 to that in 2012?
Ensure brevity in your answer.  0.87. What is the ratio of the Balance of Payment (as % of service exports) of Finland in 2011 to that in 2012?
Offer a terse response. 0.97. What is the ratio of the Balance of Payment (as % of service exports) in Guatemala in 2011 to that in 2012?
Ensure brevity in your answer.  0.8. What is the difference between the highest and the second highest Balance of Payment (as % of service exports) in South Asia?
Keep it short and to the point. 1.11. What is the difference between the highest and the second highest Balance of Payment (as % of service exports) in Bulgaria?
Keep it short and to the point. 2.9. What is the difference between the highest and the second highest Balance of Payment (as % of service exports) of Finland?
Give a very brief answer. 0.43. What is the difference between the highest and the second highest Balance of Payment (as % of service exports) in Guatemala?
Provide a short and direct response. 2.77. What is the difference between the highest and the lowest Balance of Payment (as % of service exports) of South Asia?
Your answer should be very brief. 6.38. What is the difference between the highest and the lowest Balance of Payment (as % of service exports) of Bulgaria?
Ensure brevity in your answer.  8.4. What is the difference between the highest and the lowest Balance of Payment (as % of service exports) of Finland?
Provide a succinct answer. 16.8. What is the difference between the highest and the lowest Balance of Payment (as % of service exports) of Guatemala?
Provide a succinct answer. 5.92. 